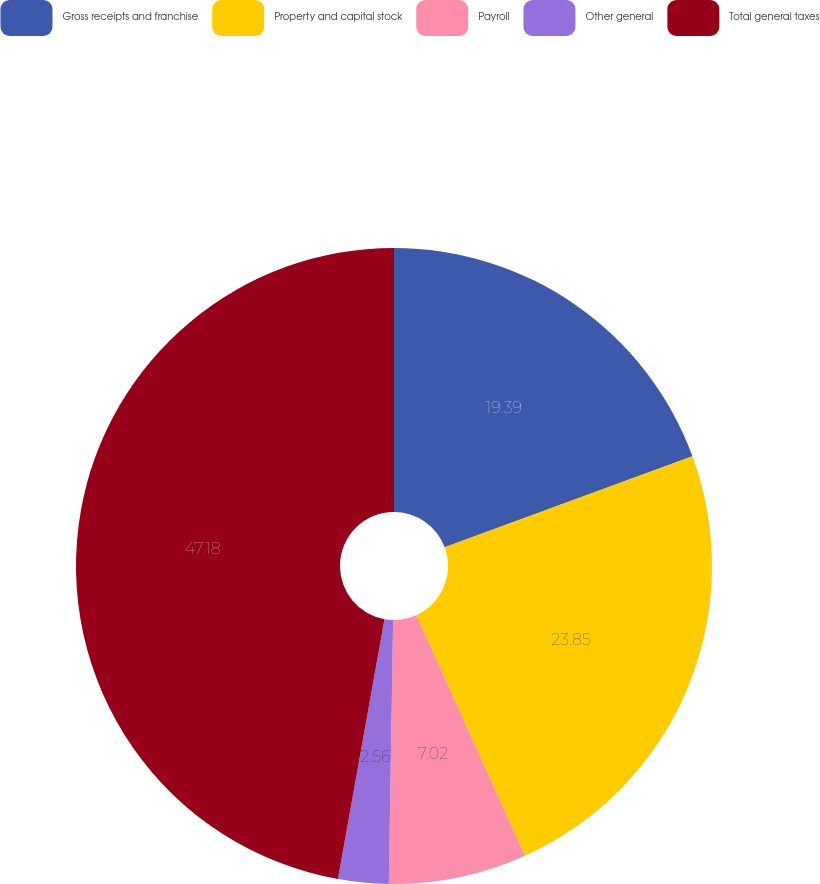Convert chart to OTSL. <chart><loc_0><loc_0><loc_500><loc_500><pie_chart><fcel>Gross receipts and franchise<fcel>Property and capital stock<fcel>Payroll<fcel>Other general<fcel>Total general taxes<nl><fcel>19.39%<fcel>23.85%<fcel>7.02%<fcel>2.56%<fcel>47.18%<nl></chart> 